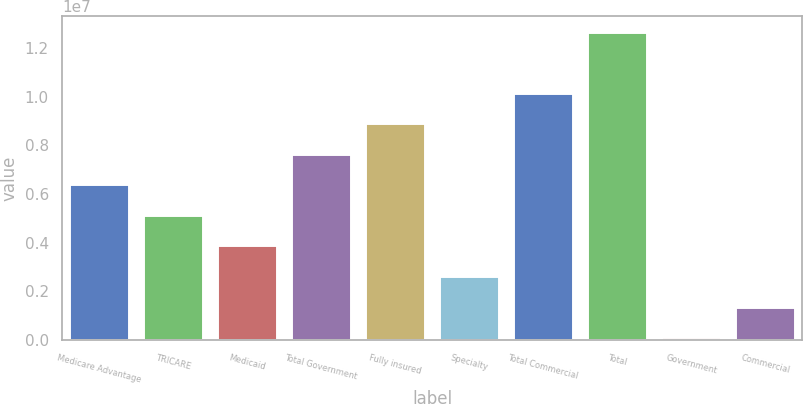Convert chart. <chart><loc_0><loc_0><loc_500><loc_500><bar_chart><fcel>Medicare Advantage<fcel>TRICARE<fcel>Medicaid<fcel>Total Government<fcel>Fully insured<fcel>Specialty<fcel>Total Commercial<fcel>Total<fcel>Government<fcel>Commercial<nl><fcel>6.3981e+06<fcel>5.13983e+06<fcel>3.88156e+06<fcel>7.65636e+06<fcel>8.91463e+06<fcel>2.6233e+06<fcel>1.01729e+07<fcel>1.26894e+07<fcel>106764<fcel>1.36503e+06<nl></chart> 